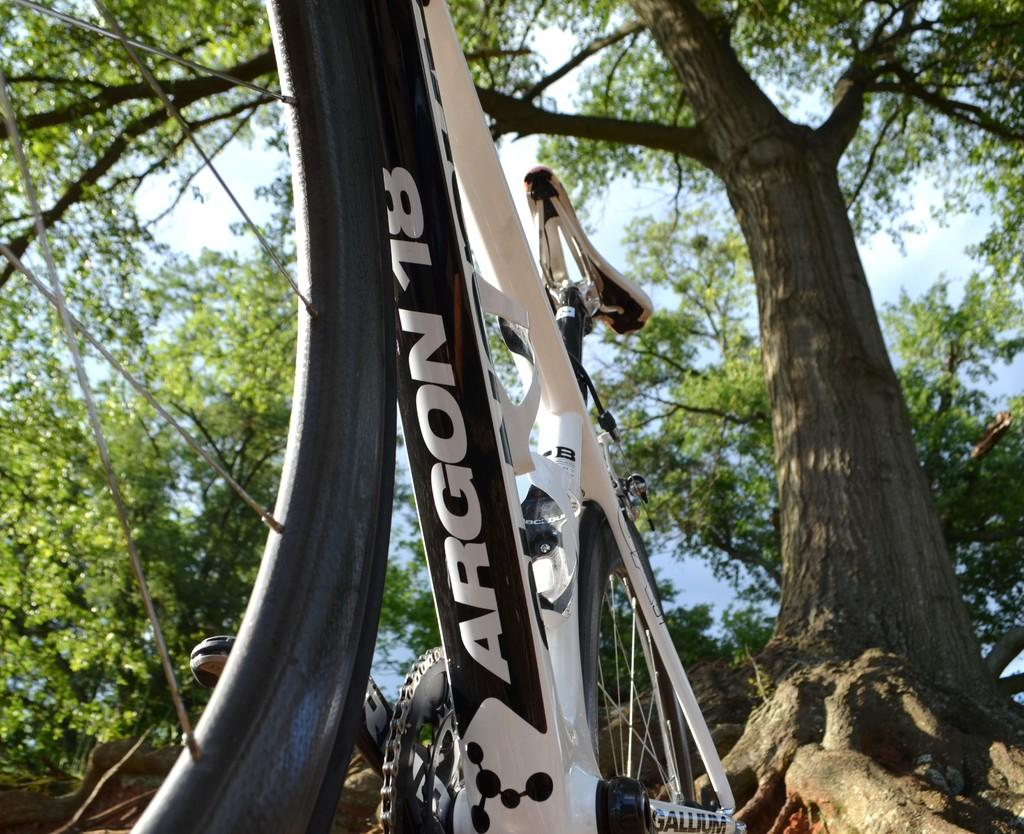What is the main object in the picture? There is a bicycle in the picture. Can you describe the color of the bicycle? The bicycle is white and black in color. What can be seen in the background of the picture? There are trees visible in the picture. How would you describe the sky in the picture? The sky is blue and cloudy. What type of religious symbol can be seen hanging from the tree in the picture? There is no religious symbol hanging from a tree in the picture; it only features a bicycle, trees, and a blue and cloudy sky. What kind of produce is growing on the tree in the picture? There are no trees with produce in the picture; it only features a bicycle and trees without any visible fruit or vegetation. 